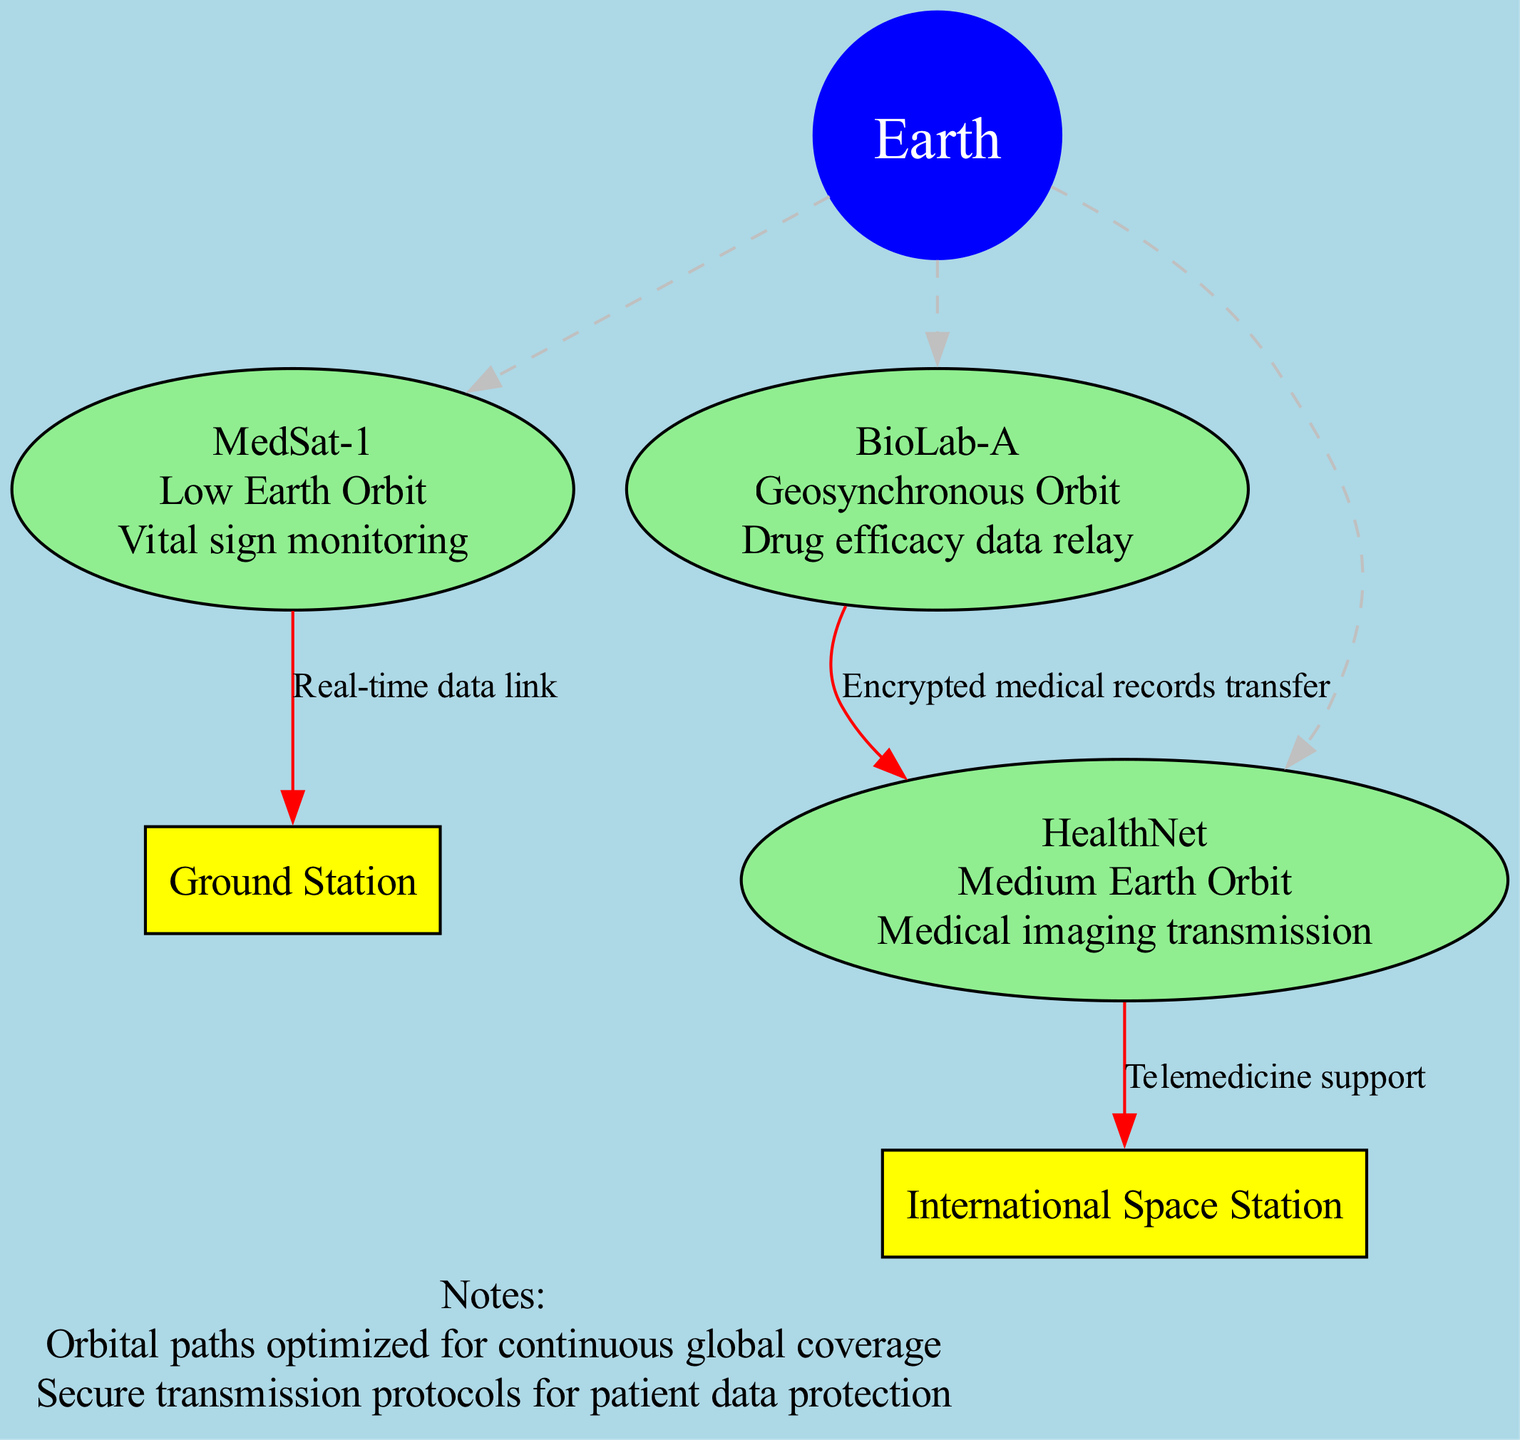What is the function of MedSat-1? The function of MedSat-1 is presented in the diagram as "Vital sign monitoring," which is located under the satellite's description box.
Answer: Vital sign monitoring How many satellites are shown in the diagram? The diagram lists three satellites: MedSat-1, BioLab-A, and HealthNet. By counting them, we determine that there are a total of three satellites depicted.
Answer: 3 What type of orbit is BioLab-A in? The orbit of BioLab-A is specified in the diagram as "Geosynchronous Orbit," which is indicated next to the satellite's name in the graphic.
Answer: Geosynchronous Orbit What connection type exists between BioLab-A and HealthNet? The diagram shows that the connection from BioLab-A to HealthNet is labeled as "Encrypted medical records transfer." This is the connection type indicated between these two nodes.
Answer: Encrypted medical records transfer Which satellite transmits medical imaging data? HealthNet is labeled in the diagram as performing the function of "Medical imaging transmission." This specifies that HealthNet is responsible for this type of data transmission.
Answer: HealthNet How many edges connect the satellites to other nodes? By analyzing the diagram, we see that there are four edges that connect the satellites—one for each satellite to Earth and additional connections for BioLab-A and HealthNet to other nodes. This results in a total of four edges connecting to other nodes.
Answer: 4 What does the note indicate about data transmission? The note in the diagram states: "Secure transmission protocols for patient data protection," which highlights the importance of secure protocols in the context of data transmission between the systems.
Answer: Secure transmission protocols for patient data protection Who supports telemedicine in this diagram? The diagram shows that HealthNet supports telemedicine as indicated by the connection labeled "Telemedicine support" from HealthNet to the International Space Station.
Answer: HealthNet 